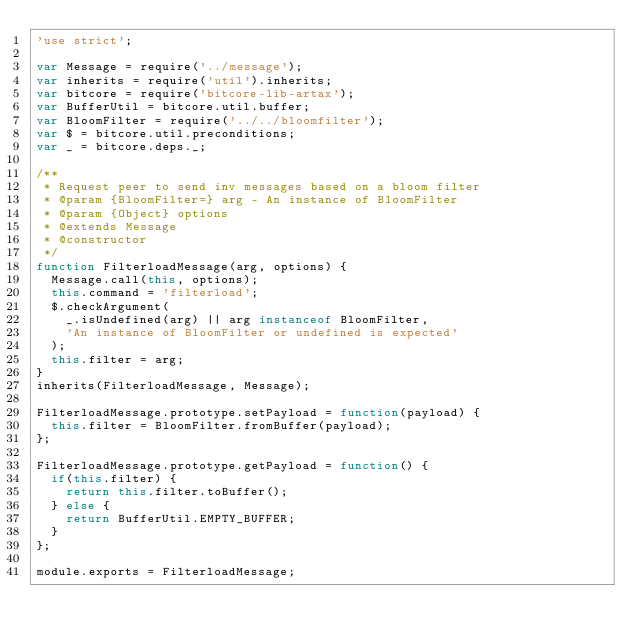<code> <loc_0><loc_0><loc_500><loc_500><_JavaScript_>'use strict';

var Message = require('../message');
var inherits = require('util').inherits;
var bitcore = require('bitcore-lib-artax');
var BufferUtil = bitcore.util.buffer;
var BloomFilter = require('../../bloomfilter');
var $ = bitcore.util.preconditions;
var _ = bitcore.deps._;

/**
 * Request peer to send inv messages based on a bloom filter
 * @param {BloomFilter=} arg - An instance of BloomFilter
 * @param {Object} options
 * @extends Message
 * @constructor
 */
function FilterloadMessage(arg, options) {
  Message.call(this, options);
  this.command = 'filterload';
  $.checkArgument(
    _.isUndefined(arg) || arg instanceof BloomFilter,
    'An instance of BloomFilter or undefined is expected'
  );
  this.filter = arg;
}
inherits(FilterloadMessage, Message);

FilterloadMessage.prototype.setPayload = function(payload) {
  this.filter = BloomFilter.fromBuffer(payload);
};

FilterloadMessage.prototype.getPayload = function() {
  if(this.filter) {
    return this.filter.toBuffer();
  } else {
    return BufferUtil.EMPTY_BUFFER;
  }
};

module.exports = FilterloadMessage;
</code> 